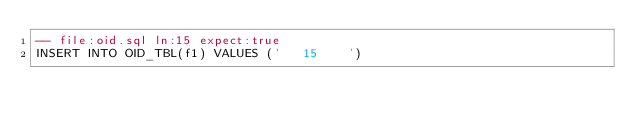Convert code to text. <code><loc_0><loc_0><loc_500><loc_500><_SQL_>-- file:oid.sql ln:15 expect:true
INSERT INTO OID_TBL(f1) VALUES ('	  15 	  ')
</code> 